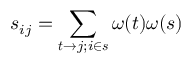<formula> <loc_0><loc_0><loc_500><loc_500>s _ { i j } = \sum _ { t \to j ; i \in s } \omega ( t ) \omega ( s )</formula> 